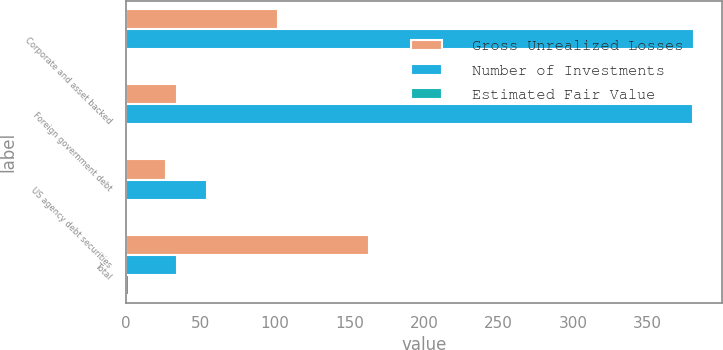Convert chart to OTSL. <chart><loc_0><loc_0><loc_500><loc_500><stacked_bar_chart><ecel><fcel>Corporate and asset backed<fcel>Foreign government debt<fcel>US agency debt securities<fcel>Total<nl><fcel>Gross Unrealized Losses<fcel>102<fcel>34<fcel>27<fcel>163<nl><fcel>Number of Investments<fcel>380.8<fcel>380.2<fcel>54.3<fcel>34<nl><fcel>Estimated Fair Value<fcel>1<fcel>1<fcel>0.1<fcel>2.1<nl></chart> 